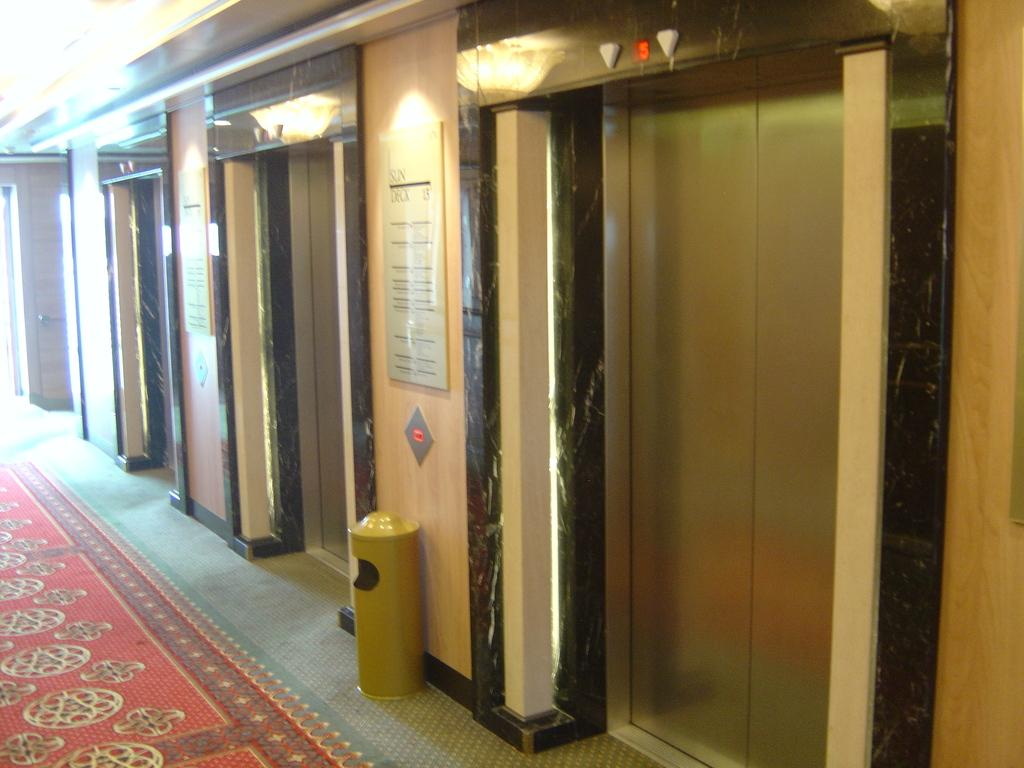What type of area is depicted in the image? There is a lift lobby in the image. What is on the floor in the image? There is a carpet on the floor in the image. What is used for waste disposal in the image? There is a trash bin in the image. What can be seen on the walls in the image? There are text boards in the image. What provides illumination in the image? There are lights attached to the ceiling in the image. Can you see any leaves falling from the ceiling in the image? There are no leaves present in the image, and the image does not depict any falling leaves. Are there any socks visible on the floor in the image? There are no socks visible on the floor in the image. 